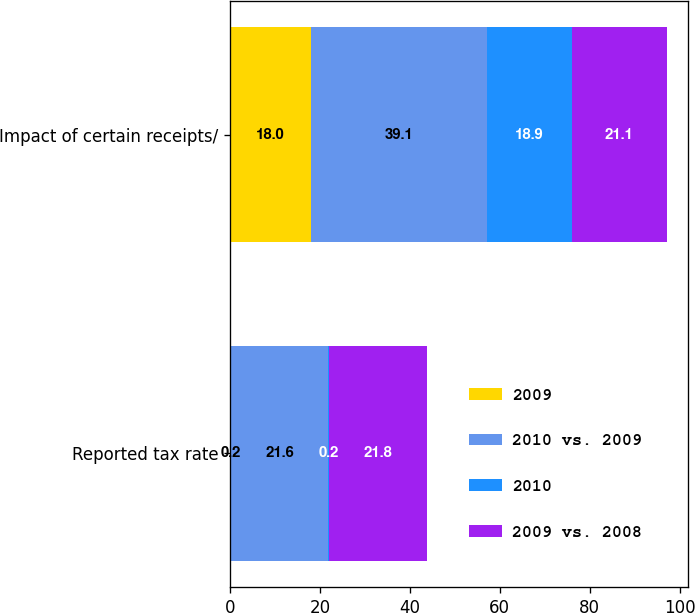<chart> <loc_0><loc_0><loc_500><loc_500><stacked_bar_chart><ecel><fcel>Reported tax rate<fcel>Impact of certain receipts/<nl><fcel>2009<fcel>0.2<fcel>18<nl><fcel>2010 vs. 2009<fcel>21.6<fcel>39.1<nl><fcel>2010<fcel>0.2<fcel>18.9<nl><fcel>2009 vs. 2008<fcel>21.8<fcel>21.1<nl></chart> 